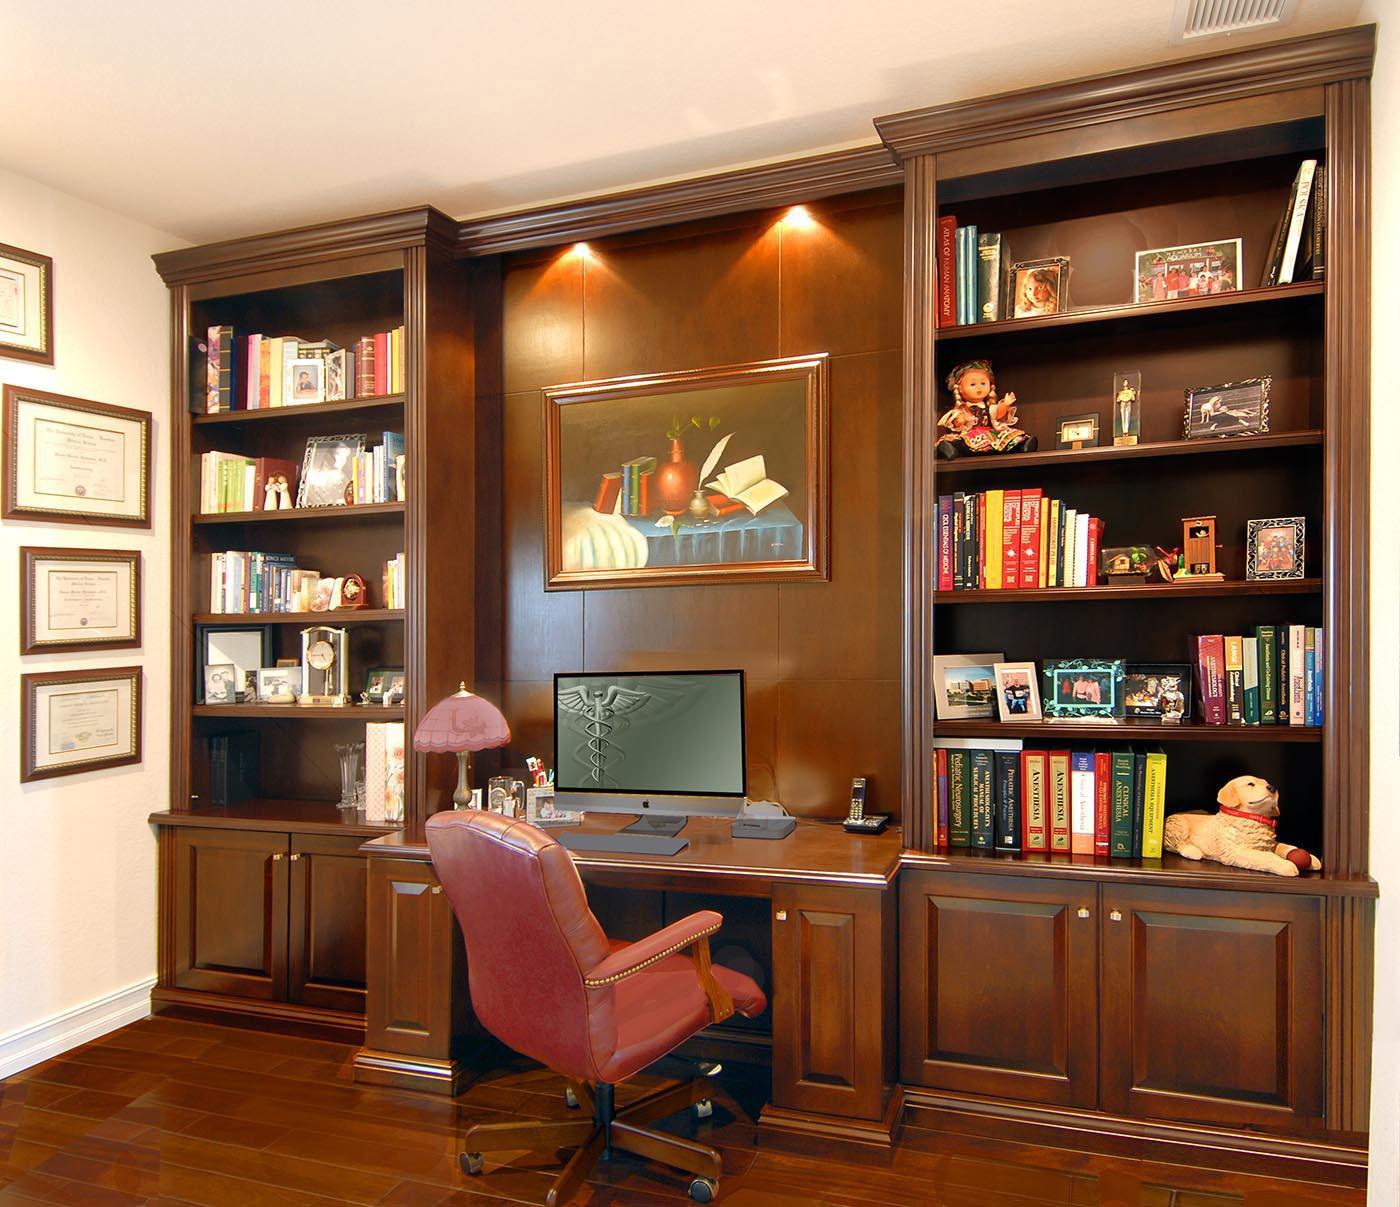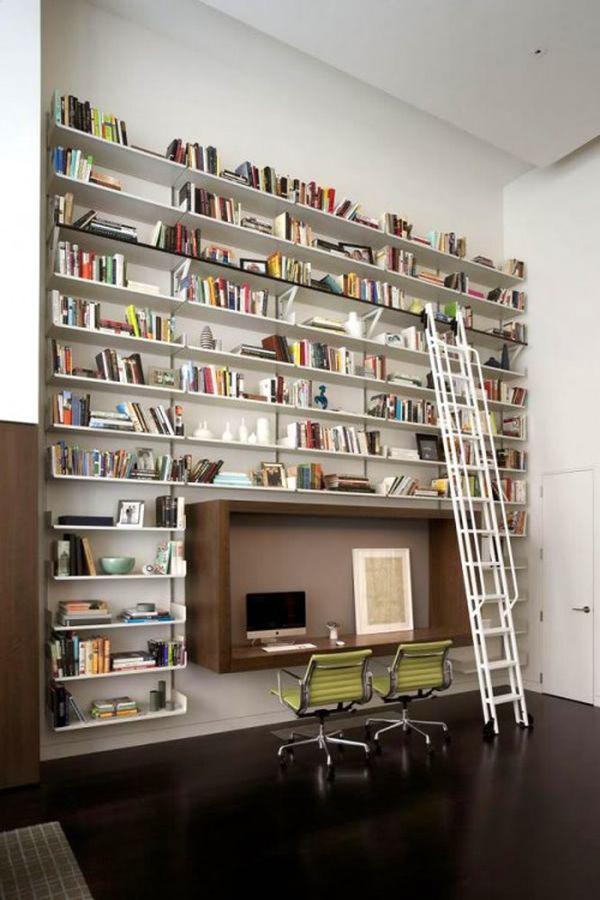The first image is the image on the left, the second image is the image on the right. Assess this claim about the two images: "The right image shows a white ladder leaned against an upper shelf of a bookcase.". Correct or not? Answer yes or no. Yes. The first image is the image on the left, the second image is the image on the right. For the images displayed, is the sentence "There is exactly one ladder." factually correct? Answer yes or no. Yes. 